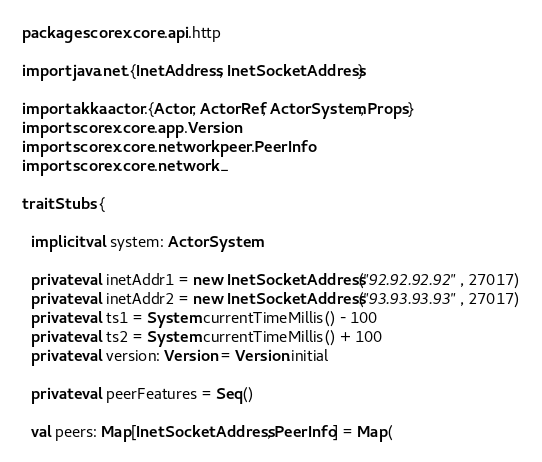<code> <loc_0><loc_0><loc_500><loc_500><_Scala_>package scorex.core.api.http

import java.net.{InetAddress, InetSocketAddress}

import akka.actor.{Actor, ActorRef, ActorSystem, Props}
import scorex.core.app.Version
import scorex.core.network.peer.PeerInfo
import scorex.core.network._

trait Stubs {

  implicit val system: ActorSystem

  private val inetAddr1 = new InetSocketAddress("92.92.92.92", 27017)
  private val inetAddr2 = new InetSocketAddress("93.93.93.93", 27017)
  private val ts1 = System.currentTimeMillis() - 100
  private val ts2 = System.currentTimeMillis() + 100
  private val version: Version = Version.initial

  private val peerFeatures = Seq()

  val peers: Map[InetSocketAddress, PeerInfo] = Map(</code> 